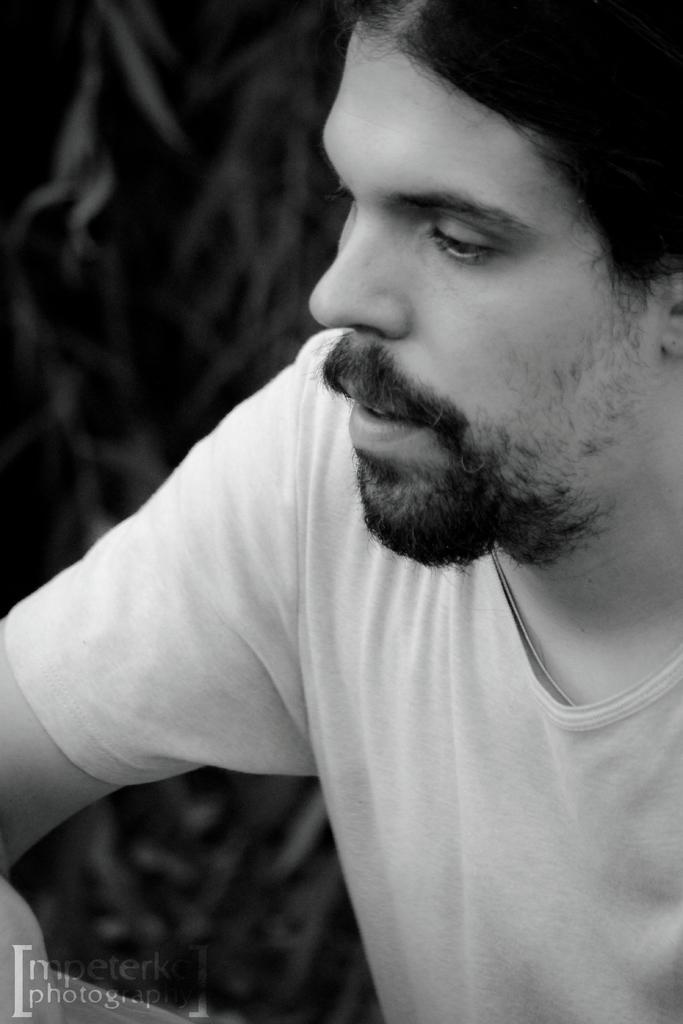Who is the main subject in the image? There is a man in the middle of the image. What can be observed about the background of the image? The background of the image is blurred. Is there any additional information or branding present in the image? Yes, there is a watermark in the bottom left side of the image. How many snakes are wrapped around the man's neck in the image? There are no snakes present in the image; the man is the main subject. 